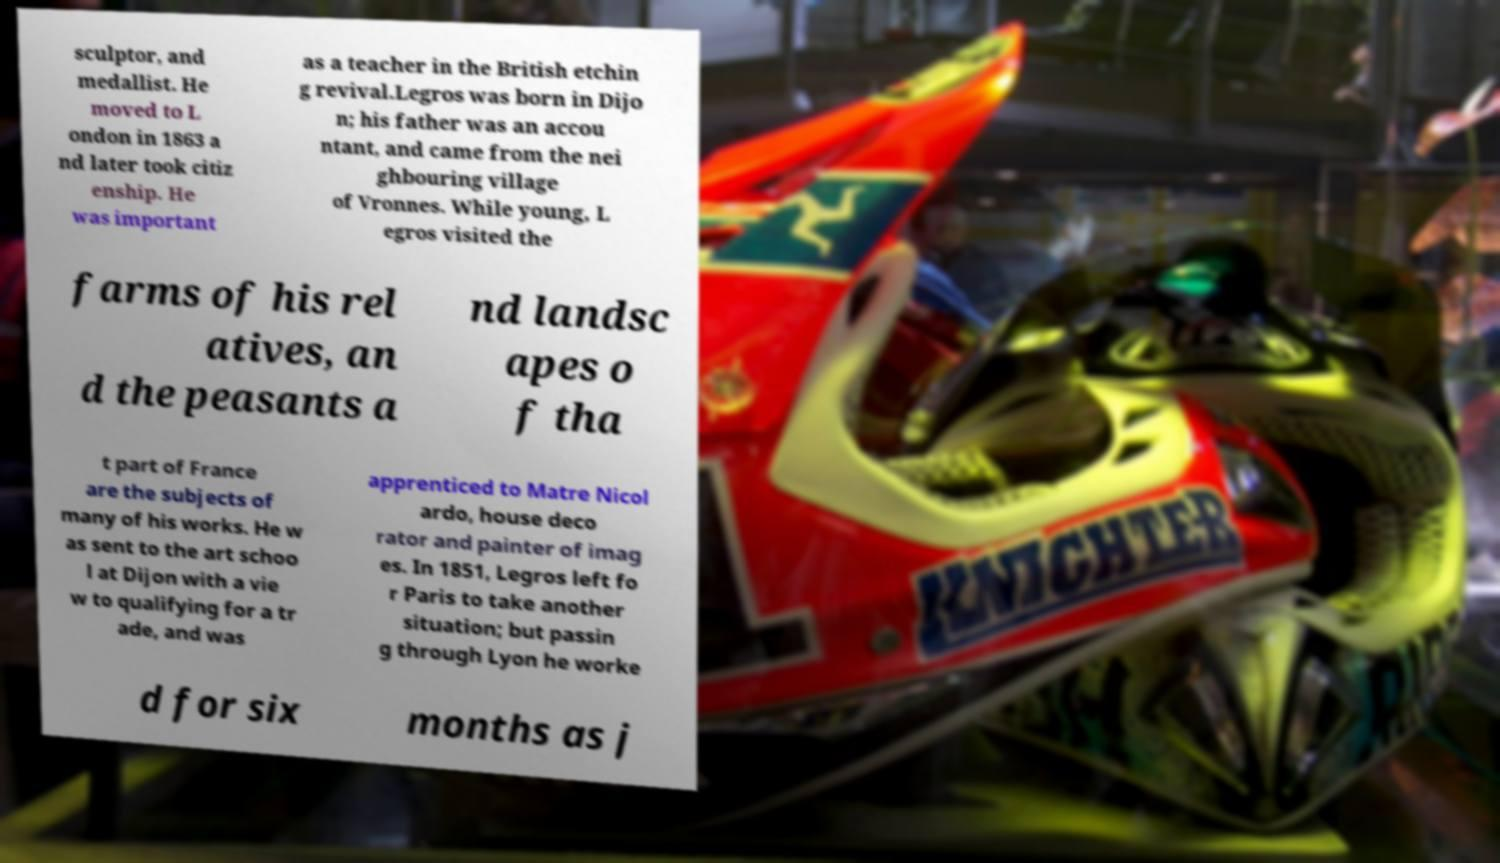There's text embedded in this image that I need extracted. Can you transcribe it verbatim? sculptor, and medallist. He moved to L ondon in 1863 a nd later took citiz enship. He was important as a teacher in the British etchin g revival.Legros was born in Dijo n; his father was an accou ntant, and came from the nei ghbouring village of Vronnes. While young, L egros visited the farms of his rel atives, an d the peasants a nd landsc apes o f tha t part of France are the subjects of many of his works. He w as sent to the art schoo l at Dijon with a vie w to qualifying for a tr ade, and was apprenticed to Matre Nicol ardo, house deco rator and painter of imag es. In 1851, Legros left fo r Paris to take another situation; but passin g through Lyon he worke d for six months as j 